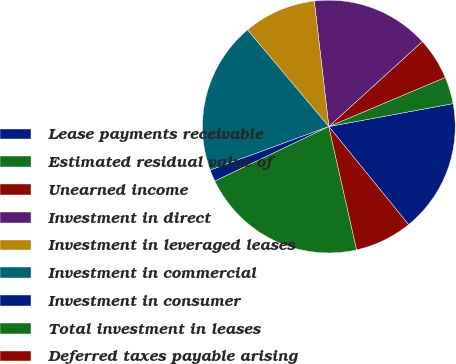Convert chart. <chart><loc_0><loc_0><loc_500><loc_500><pie_chart><fcel>Lease payments receivable<fcel>Estimated residual value of<fcel>Unearned income<fcel>Investment in direct<fcel>Investment in leveraged leases<fcel>Investment in commercial<fcel>Investment in consumer<fcel>Total investment in leases<fcel>Deferred taxes payable arising<nl><fcel>17.04%<fcel>3.45%<fcel>5.39%<fcel>15.09%<fcel>9.29%<fcel>19.48%<fcel>1.5%<fcel>21.43%<fcel>7.34%<nl></chart> 